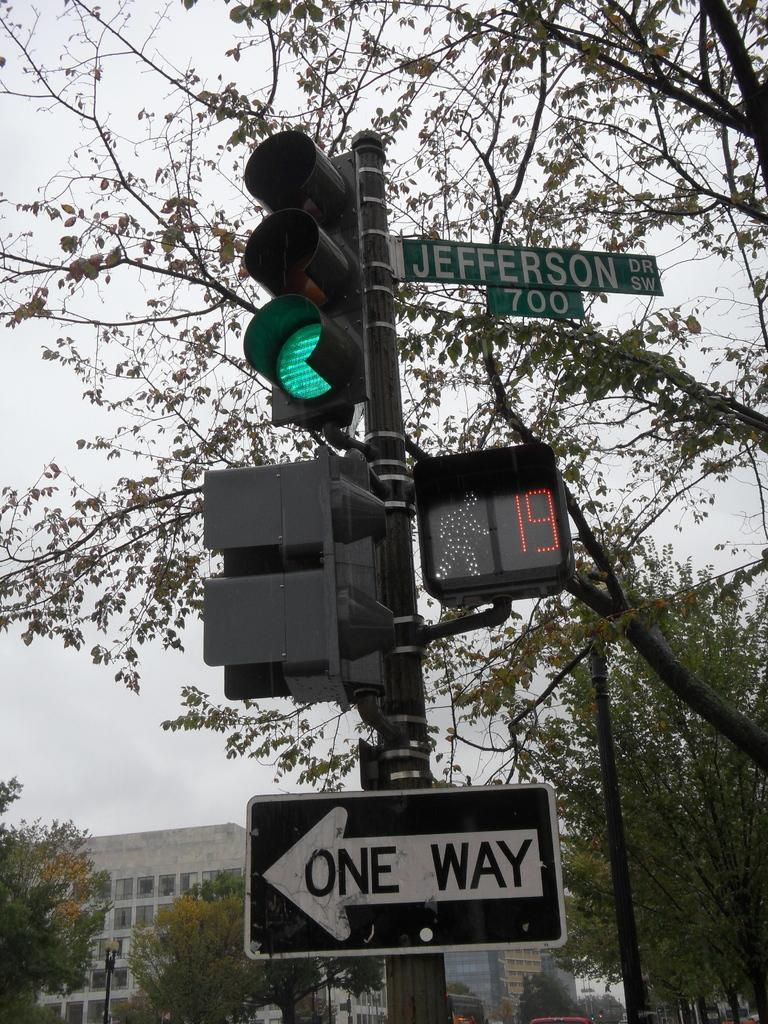<image>
Provide a brief description of the given image. Signs on a traffic light showing that Jefferson Drive is a one way street. 